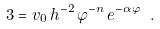<formula> <loc_0><loc_0><loc_500><loc_500>3 = v _ { 0 } \, h ^ { - 2 } \, \varphi ^ { - n } \, e ^ { - \alpha \varphi } \ .</formula> 